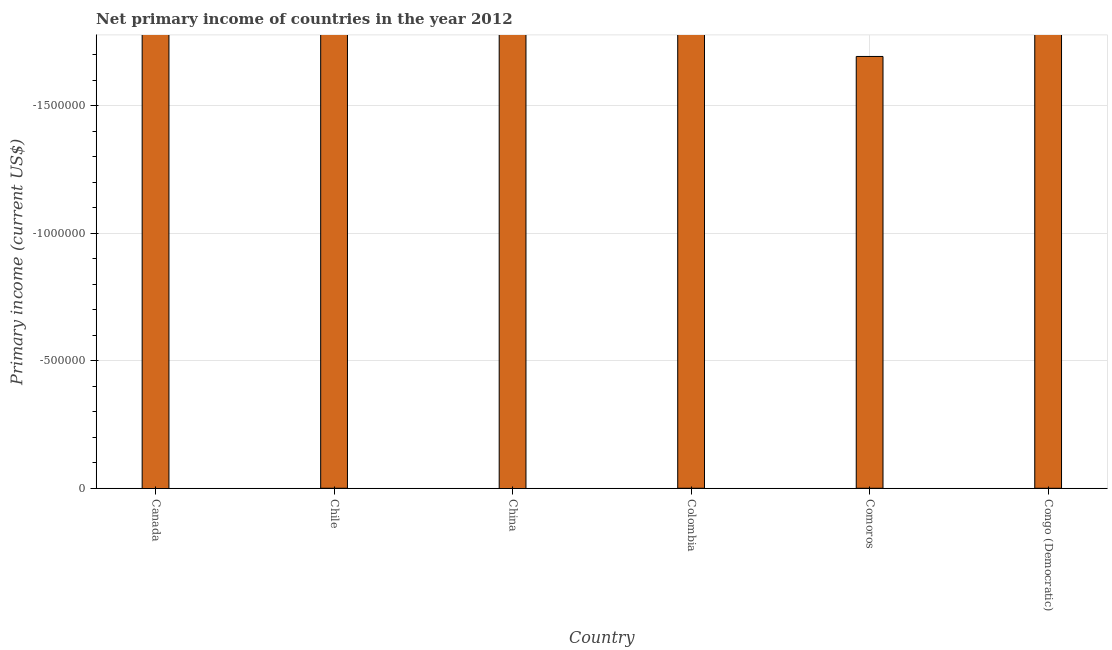Does the graph contain any zero values?
Your answer should be compact. Yes. What is the title of the graph?
Ensure brevity in your answer.  Net primary income of countries in the year 2012. What is the label or title of the Y-axis?
Give a very brief answer. Primary income (current US$). What is the amount of primary income in Comoros?
Make the answer very short. 0. What is the sum of the amount of primary income?
Offer a very short reply. 0. In how many countries, is the amount of primary income greater than the average amount of primary income taken over all countries?
Make the answer very short. 0. How many bars are there?
Provide a succinct answer. 0. Are all the bars in the graph horizontal?
Your answer should be compact. No. What is the difference between two consecutive major ticks on the Y-axis?
Provide a short and direct response. 5.00e+05. What is the Primary income (current US$) of Chile?
Your answer should be compact. 0. What is the Primary income (current US$) of Colombia?
Provide a short and direct response. 0. 